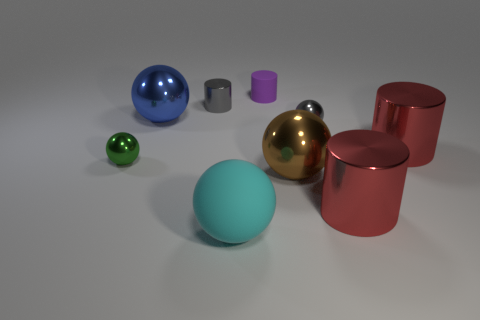There is a thing that is the same color as the small metallic cylinder; what material is it?
Your answer should be compact. Metal. What color is the large shiny cylinder that is behind the large metal ball in front of the small ball that is to the left of the cyan rubber sphere?
Your answer should be compact. Red. What number of other things are the same color as the tiny metallic cylinder?
Your answer should be very brief. 1. What number of metal things are either big cyan cylinders or gray things?
Your response must be concise. 2. Does the tiny sphere to the right of the blue thing have the same color as the shiny cylinder that is on the left side of the cyan matte ball?
Make the answer very short. Yes. What is the size of the gray metallic object that is the same shape as the green metallic object?
Provide a short and direct response. Small. Is the number of cylinders that are in front of the small matte object greater than the number of tiny cyan shiny cylinders?
Ensure brevity in your answer.  Yes. Are the tiny cylinder that is behind the gray cylinder and the cyan thing made of the same material?
Your answer should be compact. Yes. There is a gray metallic thing that is to the right of the small metallic cylinder in front of the small purple matte cylinder behind the gray sphere; what is its size?
Provide a succinct answer. Small. There is a gray cylinder that is the same material as the small green thing; what is its size?
Provide a succinct answer. Small. 